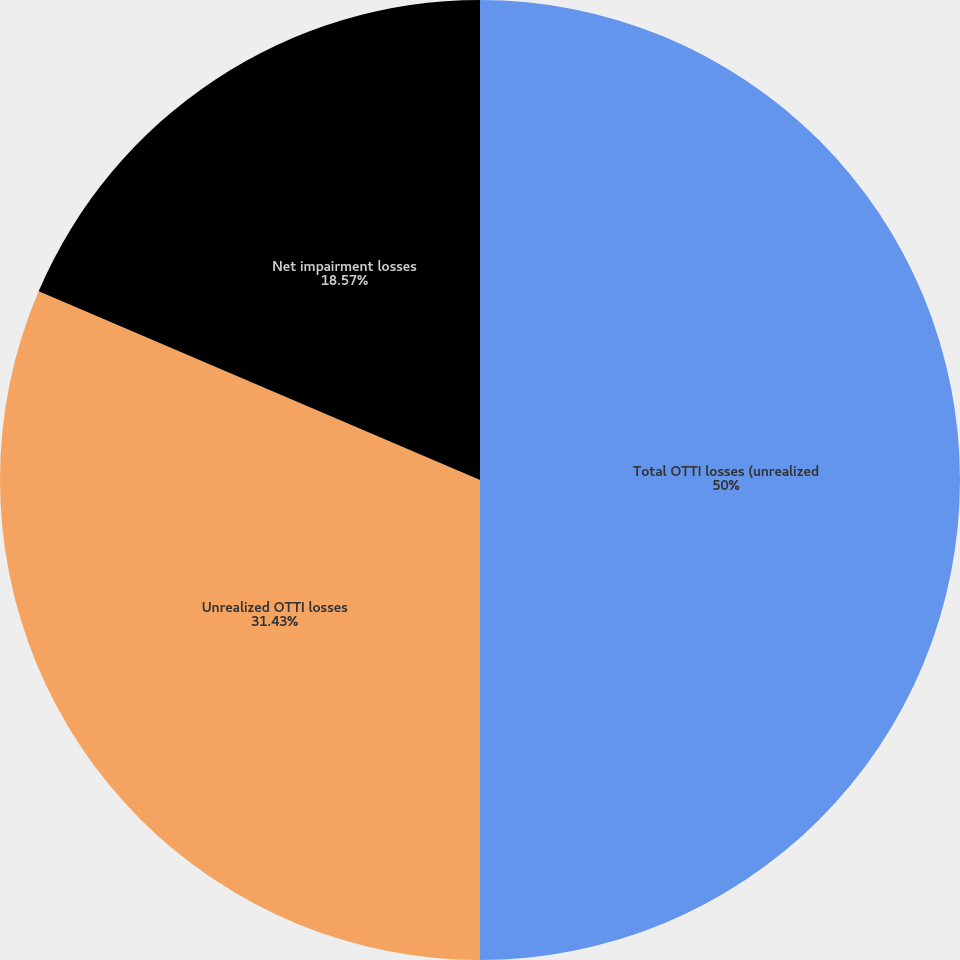Convert chart to OTSL. <chart><loc_0><loc_0><loc_500><loc_500><pie_chart><fcel>Total OTTI losses (unrealized<fcel>Unrealized OTTI losses<fcel>Net impairment losses<nl><fcel>50.0%<fcel>31.43%<fcel>18.57%<nl></chart> 